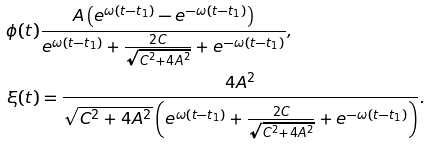<formula> <loc_0><loc_0><loc_500><loc_500>\phi ( t ) & \frac { A \left ( e ^ { \omega ( t - t _ { 1 } ) } - e ^ { - \omega ( t - t _ { 1 } ) } \right ) } { e ^ { \omega ( t - t _ { 1 } ) } + \frac { 2 C } { \sqrt { C ^ { 2 } + 4 A ^ { 2 } } } + e ^ { - \omega ( t - t _ { 1 } ) } } , \\ \xi ( t ) & = \frac { 4 A ^ { 2 } } { \sqrt { C ^ { 2 } + 4 A ^ { 2 } } \left ( e ^ { \omega ( t - t _ { 1 } ) } + \frac { 2 C } { \sqrt { C ^ { 2 } + 4 A ^ { 2 } } } + e ^ { - \omega ( t - t _ { 1 } ) } \right ) } .</formula> 